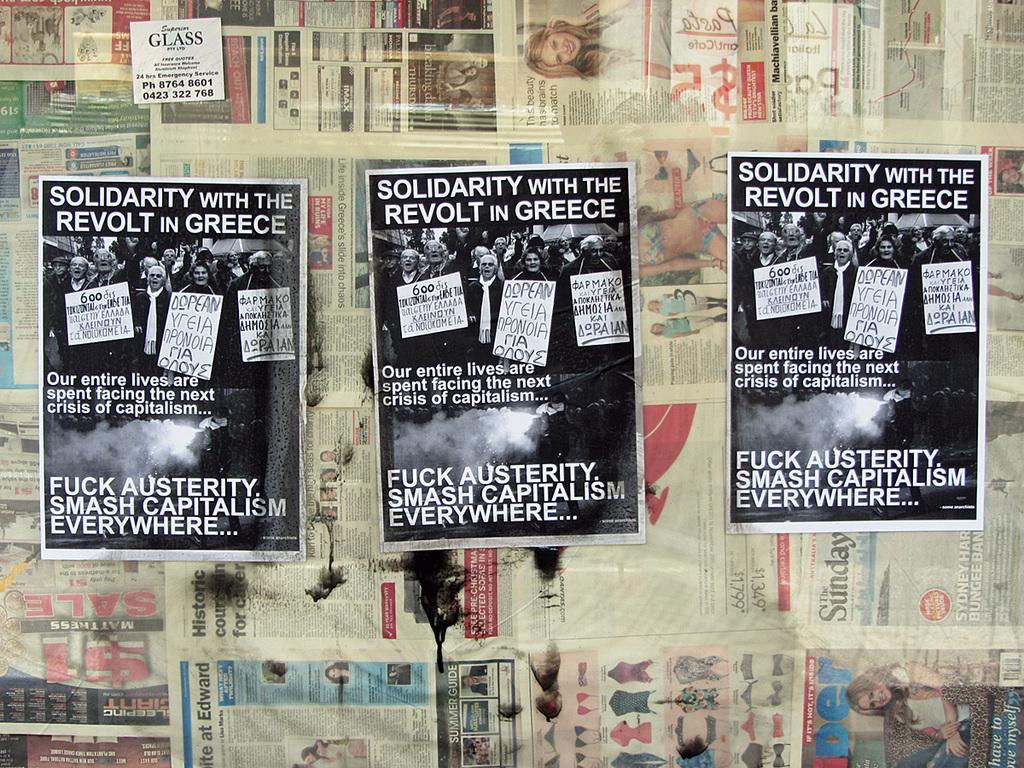Provide a one-sentence caption for the provided image. Posters that are on a wall for solidarity with the revolt in Greece. 